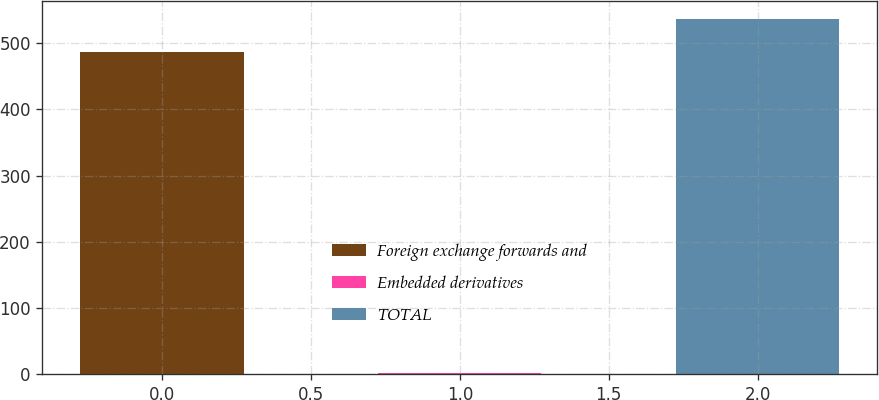<chart> <loc_0><loc_0><loc_500><loc_500><bar_chart><fcel>Foreign exchange forwards and<fcel>Embedded derivatives<fcel>TOTAL<nl><fcel>487<fcel>2<fcel>536.4<nl></chart> 